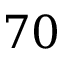<formula> <loc_0><loc_0><loc_500><loc_500>7 0</formula> 